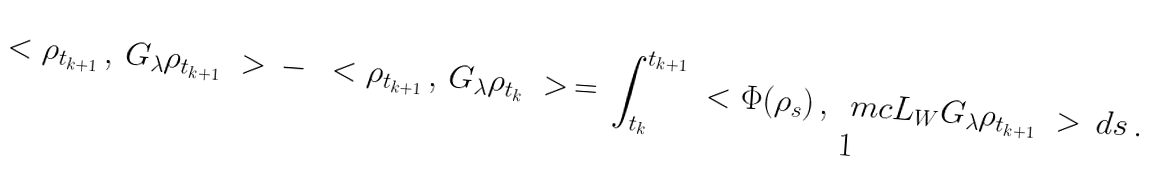Convert formula to latex. <formula><loc_0><loc_0><loc_500><loc_500>\ < \rho _ { t _ { k + 1 } } \, , \, G _ { \lambda } \rho _ { t _ { k + 1 } } \ > \, - \, \ < \rho _ { t _ { k + 1 } } \, , \, G _ { \lambda } \rho _ { t _ { k } } \ > \, = \, \int _ { t _ { k } } ^ { t _ { k + 1 } } \ < \Phi ( \rho _ { s } ) \, , \, \ m c L _ { W } G _ { \lambda } \rho _ { t _ { k + 1 } } \ > \, d s \, .</formula> 